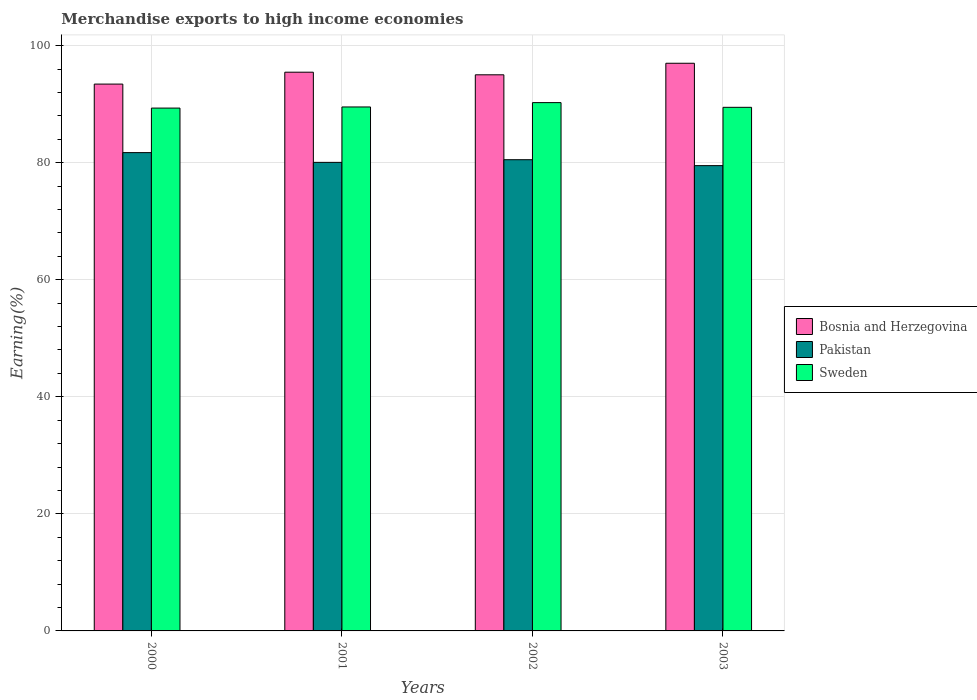How many groups of bars are there?
Ensure brevity in your answer.  4. Are the number of bars per tick equal to the number of legend labels?
Offer a terse response. Yes. How many bars are there on the 4th tick from the right?
Your response must be concise. 3. What is the label of the 3rd group of bars from the left?
Make the answer very short. 2002. What is the percentage of amount earned from merchandise exports in Pakistan in 2002?
Your answer should be very brief. 80.51. Across all years, what is the maximum percentage of amount earned from merchandise exports in Sweden?
Keep it short and to the point. 90.27. Across all years, what is the minimum percentage of amount earned from merchandise exports in Sweden?
Your response must be concise. 89.33. What is the total percentage of amount earned from merchandise exports in Sweden in the graph?
Ensure brevity in your answer.  358.59. What is the difference between the percentage of amount earned from merchandise exports in Pakistan in 2002 and that in 2003?
Offer a terse response. 1.01. What is the difference between the percentage of amount earned from merchandise exports in Sweden in 2000 and the percentage of amount earned from merchandise exports in Bosnia and Herzegovina in 2001?
Provide a short and direct response. -6.13. What is the average percentage of amount earned from merchandise exports in Pakistan per year?
Give a very brief answer. 80.45. In the year 2003, what is the difference between the percentage of amount earned from merchandise exports in Bosnia and Herzegovina and percentage of amount earned from merchandise exports in Pakistan?
Offer a terse response. 17.49. What is the ratio of the percentage of amount earned from merchandise exports in Sweden in 2002 to that in 2003?
Keep it short and to the point. 1.01. What is the difference between the highest and the second highest percentage of amount earned from merchandise exports in Sweden?
Your response must be concise. 0.74. What is the difference between the highest and the lowest percentage of amount earned from merchandise exports in Bosnia and Herzegovina?
Offer a very short reply. 3.56. In how many years, is the percentage of amount earned from merchandise exports in Sweden greater than the average percentage of amount earned from merchandise exports in Sweden taken over all years?
Your answer should be very brief. 1. Is the sum of the percentage of amount earned from merchandise exports in Bosnia and Herzegovina in 2000 and 2003 greater than the maximum percentage of amount earned from merchandise exports in Pakistan across all years?
Offer a very short reply. Yes. What does the 3rd bar from the left in 2000 represents?
Offer a terse response. Sweden. What does the 1st bar from the right in 2002 represents?
Ensure brevity in your answer.  Sweden. Are all the bars in the graph horizontal?
Provide a short and direct response. No. Does the graph contain any zero values?
Make the answer very short. No. Where does the legend appear in the graph?
Your response must be concise. Center right. How are the legend labels stacked?
Keep it short and to the point. Vertical. What is the title of the graph?
Ensure brevity in your answer.  Merchandise exports to high income economies. Does "New Caledonia" appear as one of the legend labels in the graph?
Make the answer very short. No. What is the label or title of the Y-axis?
Ensure brevity in your answer.  Earning(%). What is the Earning(%) of Bosnia and Herzegovina in 2000?
Offer a very short reply. 93.43. What is the Earning(%) of Pakistan in 2000?
Ensure brevity in your answer.  81.72. What is the Earning(%) of Sweden in 2000?
Your response must be concise. 89.33. What is the Earning(%) in Bosnia and Herzegovina in 2001?
Your answer should be very brief. 95.47. What is the Earning(%) of Pakistan in 2001?
Offer a terse response. 80.06. What is the Earning(%) in Sweden in 2001?
Make the answer very short. 89.53. What is the Earning(%) in Bosnia and Herzegovina in 2002?
Your answer should be very brief. 95.02. What is the Earning(%) of Pakistan in 2002?
Keep it short and to the point. 80.51. What is the Earning(%) of Sweden in 2002?
Provide a succinct answer. 90.27. What is the Earning(%) of Bosnia and Herzegovina in 2003?
Provide a short and direct response. 96.99. What is the Earning(%) in Pakistan in 2003?
Your answer should be compact. 79.5. What is the Earning(%) of Sweden in 2003?
Give a very brief answer. 89.46. Across all years, what is the maximum Earning(%) in Bosnia and Herzegovina?
Provide a succinct answer. 96.99. Across all years, what is the maximum Earning(%) in Pakistan?
Give a very brief answer. 81.72. Across all years, what is the maximum Earning(%) of Sweden?
Offer a very short reply. 90.27. Across all years, what is the minimum Earning(%) of Bosnia and Herzegovina?
Make the answer very short. 93.43. Across all years, what is the minimum Earning(%) of Pakistan?
Give a very brief answer. 79.5. Across all years, what is the minimum Earning(%) of Sweden?
Offer a very short reply. 89.33. What is the total Earning(%) in Bosnia and Herzegovina in the graph?
Keep it short and to the point. 380.91. What is the total Earning(%) in Pakistan in the graph?
Your answer should be compact. 321.79. What is the total Earning(%) of Sweden in the graph?
Your answer should be compact. 358.59. What is the difference between the Earning(%) in Bosnia and Herzegovina in 2000 and that in 2001?
Provide a succinct answer. -2.03. What is the difference between the Earning(%) of Pakistan in 2000 and that in 2001?
Your answer should be very brief. 1.66. What is the difference between the Earning(%) in Sweden in 2000 and that in 2001?
Offer a very short reply. -0.19. What is the difference between the Earning(%) of Bosnia and Herzegovina in 2000 and that in 2002?
Offer a very short reply. -1.58. What is the difference between the Earning(%) of Pakistan in 2000 and that in 2002?
Ensure brevity in your answer.  1.21. What is the difference between the Earning(%) of Sweden in 2000 and that in 2002?
Keep it short and to the point. -0.93. What is the difference between the Earning(%) in Bosnia and Herzegovina in 2000 and that in 2003?
Your answer should be very brief. -3.56. What is the difference between the Earning(%) of Pakistan in 2000 and that in 2003?
Make the answer very short. 2.22. What is the difference between the Earning(%) in Sweden in 2000 and that in 2003?
Provide a short and direct response. -0.13. What is the difference between the Earning(%) of Bosnia and Herzegovina in 2001 and that in 2002?
Offer a terse response. 0.45. What is the difference between the Earning(%) in Pakistan in 2001 and that in 2002?
Offer a terse response. -0.45. What is the difference between the Earning(%) in Sweden in 2001 and that in 2002?
Make the answer very short. -0.74. What is the difference between the Earning(%) in Bosnia and Herzegovina in 2001 and that in 2003?
Your answer should be very brief. -1.53. What is the difference between the Earning(%) in Pakistan in 2001 and that in 2003?
Provide a succinct answer. 0.56. What is the difference between the Earning(%) in Sweden in 2001 and that in 2003?
Provide a short and direct response. 0.06. What is the difference between the Earning(%) in Bosnia and Herzegovina in 2002 and that in 2003?
Ensure brevity in your answer.  -1.97. What is the difference between the Earning(%) in Pakistan in 2002 and that in 2003?
Ensure brevity in your answer.  1.01. What is the difference between the Earning(%) of Sweden in 2002 and that in 2003?
Your response must be concise. 0.8. What is the difference between the Earning(%) in Bosnia and Herzegovina in 2000 and the Earning(%) in Pakistan in 2001?
Keep it short and to the point. 13.38. What is the difference between the Earning(%) in Bosnia and Herzegovina in 2000 and the Earning(%) in Sweden in 2001?
Give a very brief answer. 3.91. What is the difference between the Earning(%) of Pakistan in 2000 and the Earning(%) of Sweden in 2001?
Your answer should be compact. -7.8. What is the difference between the Earning(%) of Bosnia and Herzegovina in 2000 and the Earning(%) of Pakistan in 2002?
Keep it short and to the point. 12.92. What is the difference between the Earning(%) in Bosnia and Herzegovina in 2000 and the Earning(%) in Sweden in 2002?
Give a very brief answer. 3.17. What is the difference between the Earning(%) in Pakistan in 2000 and the Earning(%) in Sweden in 2002?
Offer a terse response. -8.54. What is the difference between the Earning(%) in Bosnia and Herzegovina in 2000 and the Earning(%) in Pakistan in 2003?
Keep it short and to the point. 13.93. What is the difference between the Earning(%) of Bosnia and Herzegovina in 2000 and the Earning(%) of Sweden in 2003?
Make the answer very short. 3.97. What is the difference between the Earning(%) of Pakistan in 2000 and the Earning(%) of Sweden in 2003?
Keep it short and to the point. -7.74. What is the difference between the Earning(%) of Bosnia and Herzegovina in 2001 and the Earning(%) of Pakistan in 2002?
Your response must be concise. 14.95. What is the difference between the Earning(%) in Bosnia and Herzegovina in 2001 and the Earning(%) in Sweden in 2002?
Keep it short and to the point. 5.2. What is the difference between the Earning(%) in Pakistan in 2001 and the Earning(%) in Sweden in 2002?
Your answer should be compact. -10.21. What is the difference between the Earning(%) of Bosnia and Herzegovina in 2001 and the Earning(%) of Pakistan in 2003?
Make the answer very short. 15.96. What is the difference between the Earning(%) of Bosnia and Herzegovina in 2001 and the Earning(%) of Sweden in 2003?
Provide a succinct answer. 6. What is the difference between the Earning(%) of Pakistan in 2001 and the Earning(%) of Sweden in 2003?
Your response must be concise. -9.41. What is the difference between the Earning(%) in Bosnia and Herzegovina in 2002 and the Earning(%) in Pakistan in 2003?
Make the answer very short. 15.52. What is the difference between the Earning(%) in Bosnia and Herzegovina in 2002 and the Earning(%) in Sweden in 2003?
Ensure brevity in your answer.  5.55. What is the difference between the Earning(%) in Pakistan in 2002 and the Earning(%) in Sweden in 2003?
Your answer should be compact. -8.95. What is the average Earning(%) in Bosnia and Herzegovina per year?
Provide a short and direct response. 95.23. What is the average Earning(%) in Pakistan per year?
Your answer should be very brief. 80.45. What is the average Earning(%) of Sweden per year?
Offer a terse response. 89.65. In the year 2000, what is the difference between the Earning(%) in Bosnia and Herzegovina and Earning(%) in Pakistan?
Give a very brief answer. 11.71. In the year 2000, what is the difference between the Earning(%) of Bosnia and Herzegovina and Earning(%) of Sweden?
Give a very brief answer. 4.1. In the year 2000, what is the difference between the Earning(%) in Pakistan and Earning(%) in Sweden?
Your answer should be compact. -7.61. In the year 2001, what is the difference between the Earning(%) of Bosnia and Herzegovina and Earning(%) of Pakistan?
Make the answer very short. 15.41. In the year 2001, what is the difference between the Earning(%) of Bosnia and Herzegovina and Earning(%) of Sweden?
Offer a terse response. 5.94. In the year 2001, what is the difference between the Earning(%) of Pakistan and Earning(%) of Sweden?
Offer a very short reply. -9.47. In the year 2002, what is the difference between the Earning(%) in Bosnia and Herzegovina and Earning(%) in Pakistan?
Offer a very short reply. 14.51. In the year 2002, what is the difference between the Earning(%) of Bosnia and Herzegovina and Earning(%) of Sweden?
Give a very brief answer. 4.75. In the year 2002, what is the difference between the Earning(%) in Pakistan and Earning(%) in Sweden?
Offer a terse response. -9.75. In the year 2003, what is the difference between the Earning(%) in Bosnia and Herzegovina and Earning(%) in Pakistan?
Provide a short and direct response. 17.49. In the year 2003, what is the difference between the Earning(%) in Bosnia and Herzegovina and Earning(%) in Sweden?
Provide a succinct answer. 7.53. In the year 2003, what is the difference between the Earning(%) in Pakistan and Earning(%) in Sweden?
Make the answer very short. -9.96. What is the ratio of the Earning(%) of Bosnia and Herzegovina in 2000 to that in 2001?
Offer a terse response. 0.98. What is the ratio of the Earning(%) in Pakistan in 2000 to that in 2001?
Provide a short and direct response. 1.02. What is the ratio of the Earning(%) of Sweden in 2000 to that in 2001?
Keep it short and to the point. 1. What is the ratio of the Earning(%) in Bosnia and Herzegovina in 2000 to that in 2002?
Offer a terse response. 0.98. What is the ratio of the Earning(%) in Bosnia and Herzegovina in 2000 to that in 2003?
Offer a terse response. 0.96. What is the ratio of the Earning(%) in Pakistan in 2000 to that in 2003?
Provide a succinct answer. 1.03. What is the ratio of the Earning(%) in Bosnia and Herzegovina in 2001 to that in 2002?
Ensure brevity in your answer.  1. What is the ratio of the Earning(%) of Pakistan in 2001 to that in 2002?
Make the answer very short. 0.99. What is the ratio of the Earning(%) in Sweden in 2001 to that in 2002?
Offer a very short reply. 0.99. What is the ratio of the Earning(%) of Bosnia and Herzegovina in 2001 to that in 2003?
Your response must be concise. 0.98. What is the ratio of the Earning(%) in Pakistan in 2001 to that in 2003?
Offer a terse response. 1.01. What is the ratio of the Earning(%) of Bosnia and Herzegovina in 2002 to that in 2003?
Your response must be concise. 0.98. What is the ratio of the Earning(%) in Pakistan in 2002 to that in 2003?
Keep it short and to the point. 1.01. What is the ratio of the Earning(%) of Sweden in 2002 to that in 2003?
Your answer should be compact. 1.01. What is the difference between the highest and the second highest Earning(%) of Bosnia and Herzegovina?
Your answer should be very brief. 1.53. What is the difference between the highest and the second highest Earning(%) of Pakistan?
Make the answer very short. 1.21. What is the difference between the highest and the second highest Earning(%) in Sweden?
Offer a very short reply. 0.74. What is the difference between the highest and the lowest Earning(%) of Bosnia and Herzegovina?
Offer a very short reply. 3.56. What is the difference between the highest and the lowest Earning(%) of Pakistan?
Make the answer very short. 2.22. What is the difference between the highest and the lowest Earning(%) of Sweden?
Your response must be concise. 0.93. 